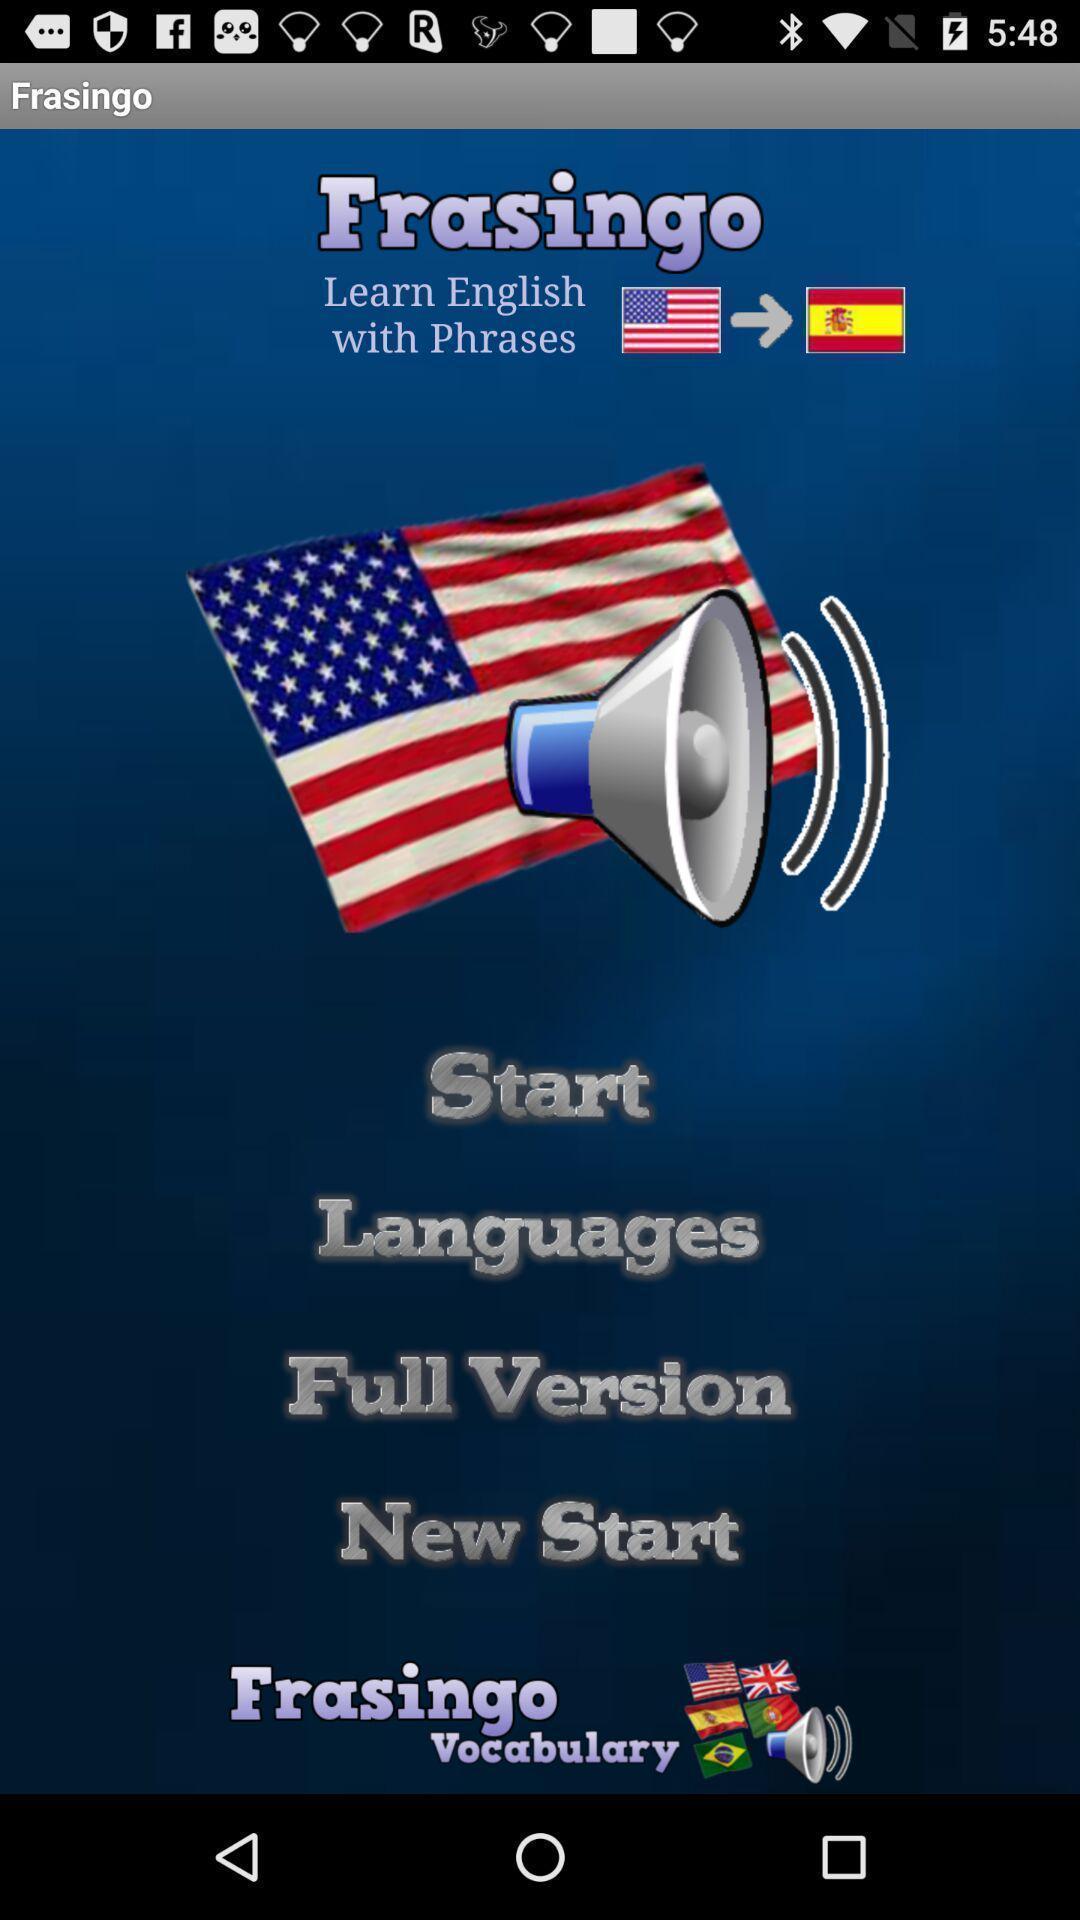Describe the visual elements of this screenshot. Welcome page of a learning app. 